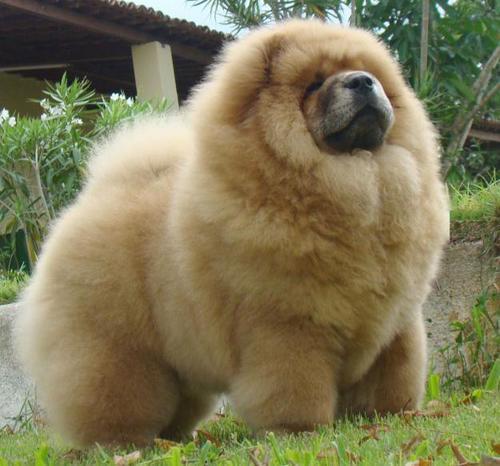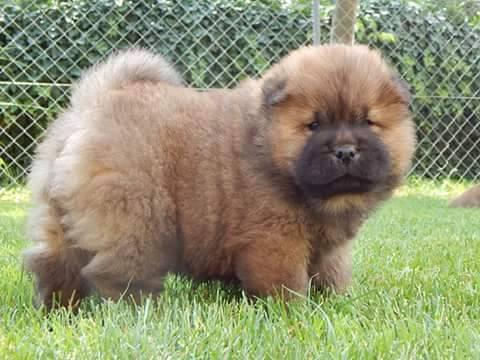The first image is the image on the left, the second image is the image on the right. Assess this claim about the two images: "Both of the images feature a dog standing on grass.". Correct or not? Answer yes or no. Yes. The first image is the image on the left, the second image is the image on the right. Evaluate the accuracy of this statement regarding the images: "Both images feature young chow puppies, and the puppies on the left and right share similar poses with bodies turned in the same direction, but the puppy on the left is not on grass.". Is it true? Answer yes or no. No. 